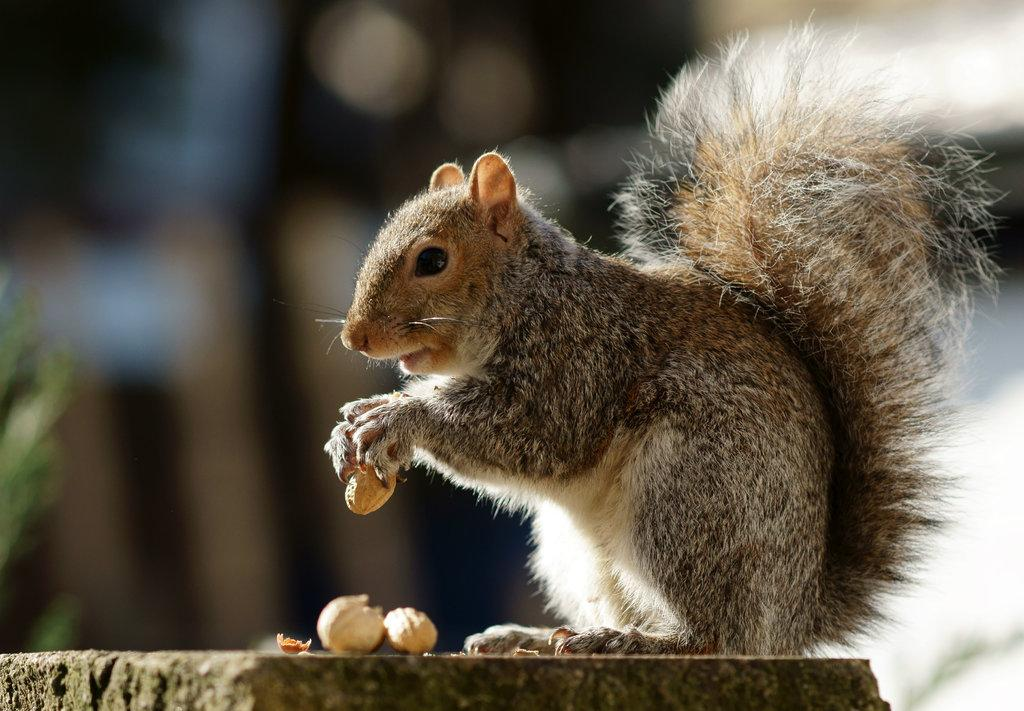What animal can be seen in the image? There is a squirrel in the image. What is the squirrel doing in the image? The squirrel is holding an object and standing on a surface. What is in front of the squirrel? There are objects in front of the squirrel. How is the background behind the squirrel depicted? The background behind the squirrel is blurred. Can you tell me how many noses the tiger has in the image? There is no tiger present in the image, so it is not possible to determine the number of noses it might have. 